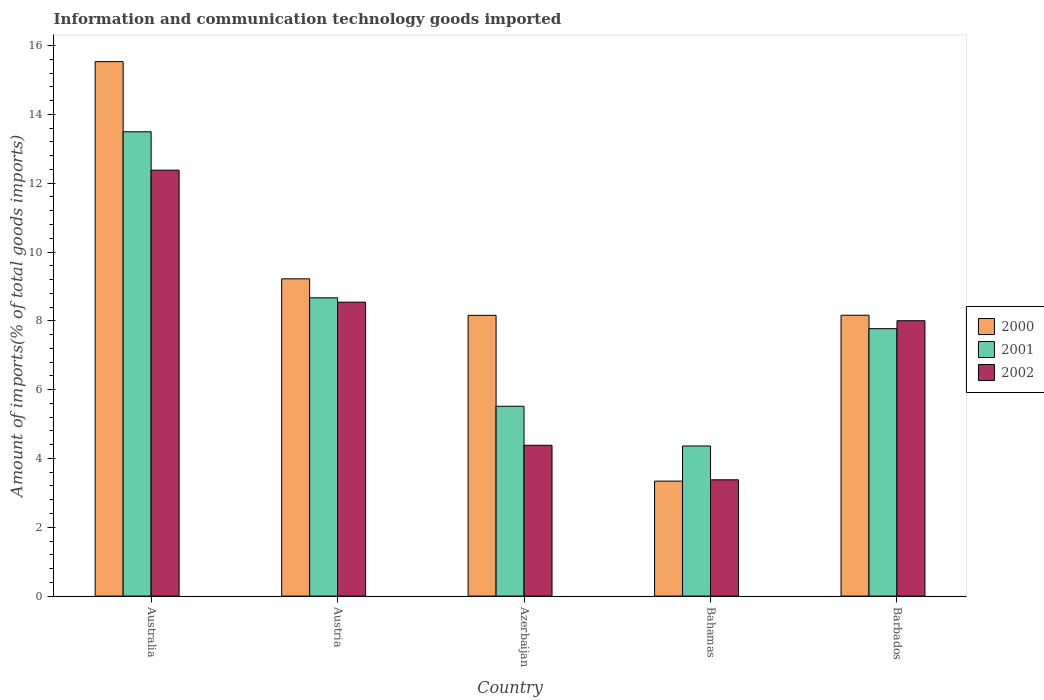How many different coloured bars are there?
Offer a very short reply. 3. How many groups of bars are there?
Your answer should be very brief. 5. Are the number of bars on each tick of the X-axis equal?
Your answer should be very brief. Yes. How many bars are there on the 5th tick from the left?
Keep it short and to the point. 3. What is the label of the 1st group of bars from the left?
Make the answer very short. Australia. In how many cases, is the number of bars for a given country not equal to the number of legend labels?
Your answer should be very brief. 0. What is the amount of goods imported in 2000 in Barbados?
Ensure brevity in your answer.  8.16. Across all countries, what is the maximum amount of goods imported in 2001?
Give a very brief answer. 13.49. Across all countries, what is the minimum amount of goods imported in 2001?
Offer a very short reply. 4.36. In which country was the amount of goods imported in 2000 minimum?
Make the answer very short. Bahamas. What is the total amount of goods imported in 2000 in the graph?
Your answer should be very brief. 44.42. What is the difference between the amount of goods imported in 2002 in Australia and that in Bahamas?
Your answer should be very brief. 9. What is the difference between the amount of goods imported in 2000 in Australia and the amount of goods imported in 2002 in Barbados?
Your answer should be very brief. 7.53. What is the average amount of goods imported in 2001 per country?
Your answer should be compact. 7.96. What is the difference between the amount of goods imported of/in 2001 and amount of goods imported of/in 2002 in Bahamas?
Offer a terse response. 0.98. In how many countries, is the amount of goods imported in 2001 greater than 11.6 %?
Provide a succinct answer. 1. What is the ratio of the amount of goods imported in 2001 in Australia to that in Azerbaijan?
Your answer should be compact. 2.45. Is the difference between the amount of goods imported in 2001 in Australia and Bahamas greater than the difference between the amount of goods imported in 2002 in Australia and Bahamas?
Make the answer very short. Yes. What is the difference between the highest and the second highest amount of goods imported in 2000?
Provide a short and direct response. -1.06. What is the difference between the highest and the lowest amount of goods imported in 2002?
Offer a very short reply. 9. What does the 2nd bar from the left in Austria represents?
Your answer should be very brief. 2001. Is it the case that in every country, the sum of the amount of goods imported in 2002 and amount of goods imported in 2001 is greater than the amount of goods imported in 2000?
Keep it short and to the point. Yes. How many bars are there?
Ensure brevity in your answer.  15. How many countries are there in the graph?
Your response must be concise. 5. What is the difference between two consecutive major ticks on the Y-axis?
Make the answer very short. 2. Are the values on the major ticks of Y-axis written in scientific E-notation?
Your answer should be very brief. No. Does the graph contain grids?
Offer a very short reply. No. Where does the legend appear in the graph?
Ensure brevity in your answer.  Center right. How are the legend labels stacked?
Make the answer very short. Vertical. What is the title of the graph?
Your response must be concise. Information and communication technology goods imported. What is the label or title of the Y-axis?
Offer a very short reply. Amount of imports(% of total goods imports). What is the Amount of imports(% of total goods imports) in 2000 in Australia?
Offer a terse response. 15.53. What is the Amount of imports(% of total goods imports) of 2001 in Australia?
Make the answer very short. 13.49. What is the Amount of imports(% of total goods imports) in 2002 in Australia?
Make the answer very short. 12.38. What is the Amount of imports(% of total goods imports) in 2000 in Austria?
Make the answer very short. 9.22. What is the Amount of imports(% of total goods imports) of 2001 in Austria?
Offer a very short reply. 8.67. What is the Amount of imports(% of total goods imports) in 2002 in Austria?
Offer a very short reply. 8.54. What is the Amount of imports(% of total goods imports) in 2000 in Azerbaijan?
Offer a very short reply. 8.16. What is the Amount of imports(% of total goods imports) of 2001 in Azerbaijan?
Provide a succinct answer. 5.52. What is the Amount of imports(% of total goods imports) in 2002 in Azerbaijan?
Your answer should be compact. 4.38. What is the Amount of imports(% of total goods imports) of 2000 in Bahamas?
Keep it short and to the point. 3.34. What is the Amount of imports(% of total goods imports) in 2001 in Bahamas?
Provide a short and direct response. 4.36. What is the Amount of imports(% of total goods imports) of 2002 in Bahamas?
Provide a short and direct response. 3.38. What is the Amount of imports(% of total goods imports) of 2000 in Barbados?
Keep it short and to the point. 8.16. What is the Amount of imports(% of total goods imports) in 2001 in Barbados?
Your response must be concise. 7.77. What is the Amount of imports(% of total goods imports) of 2002 in Barbados?
Ensure brevity in your answer.  8. Across all countries, what is the maximum Amount of imports(% of total goods imports) of 2000?
Your answer should be compact. 15.53. Across all countries, what is the maximum Amount of imports(% of total goods imports) in 2001?
Provide a short and direct response. 13.49. Across all countries, what is the maximum Amount of imports(% of total goods imports) of 2002?
Offer a terse response. 12.38. Across all countries, what is the minimum Amount of imports(% of total goods imports) of 2000?
Provide a succinct answer. 3.34. Across all countries, what is the minimum Amount of imports(% of total goods imports) of 2001?
Make the answer very short. 4.36. Across all countries, what is the minimum Amount of imports(% of total goods imports) of 2002?
Provide a succinct answer. 3.38. What is the total Amount of imports(% of total goods imports) in 2000 in the graph?
Give a very brief answer. 44.42. What is the total Amount of imports(% of total goods imports) in 2001 in the graph?
Make the answer very short. 39.82. What is the total Amount of imports(% of total goods imports) in 2002 in the graph?
Provide a succinct answer. 36.69. What is the difference between the Amount of imports(% of total goods imports) of 2000 in Australia and that in Austria?
Make the answer very short. 6.31. What is the difference between the Amount of imports(% of total goods imports) of 2001 in Australia and that in Austria?
Offer a terse response. 4.83. What is the difference between the Amount of imports(% of total goods imports) in 2002 in Australia and that in Austria?
Provide a succinct answer. 3.84. What is the difference between the Amount of imports(% of total goods imports) of 2000 in Australia and that in Azerbaijan?
Ensure brevity in your answer.  7.37. What is the difference between the Amount of imports(% of total goods imports) of 2001 in Australia and that in Azerbaijan?
Keep it short and to the point. 7.98. What is the difference between the Amount of imports(% of total goods imports) in 2002 in Australia and that in Azerbaijan?
Your answer should be very brief. 8. What is the difference between the Amount of imports(% of total goods imports) in 2000 in Australia and that in Bahamas?
Ensure brevity in your answer.  12.19. What is the difference between the Amount of imports(% of total goods imports) of 2001 in Australia and that in Bahamas?
Your response must be concise. 9.13. What is the difference between the Amount of imports(% of total goods imports) of 2002 in Australia and that in Bahamas?
Offer a very short reply. 9. What is the difference between the Amount of imports(% of total goods imports) in 2000 in Australia and that in Barbados?
Give a very brief answer. 7.37. What is the difference between the Amount of imports(% of total goods imports) in 2001 in Australia and that in Barbados?
Ensure brevity in your answer.  5.72. What is the difference between the Amount of imports(% of total goods imports) of 2002 in Australia and that in Barbados?
Offer a very short reply. 4.38. What is the difference between the Amount of imports(% of total goods imports) of 2000 in Austria and that in Azerbaijan?
Provide a succinct answer. 1.06. What is the difference between the Amount of imports(% of total goods imports) in 2001 in Austria and that in Azerbaijan?
Make the answer very short. 3.15. What is the difference between the Amount of imports(% of total goods imports) of 2002 in Austria and that in Azerbaijan?
Your answer should be very brief. 4.16. What is the difference between the Amount of imports(% of total goods imports) in 2000 in Austria and that in Bahamas?
Provide a short and direct response. 5.88. What is the difference between the Amount of imports(% of total goods imports) of 2001 in Austria and that in Bahamas?
Offer a very short reply. 4.31. What is the difference between the Amount of imports(% of total goods imports) in 2002 in Austria and that in Bahamas?
Your response must be concise. 5.16. What is the difference between the Amount of imports(% of total goods imports) of 2000 in Austria and that in Barbados?
Ensure brevity in your answer.  1.06. What is the difference between the Amount of imports(% of total goods imports) in 2001 in Austria and that in Barbados?
Your response must be concise. 0.9. What is the difference between the Amount of imports(% of total goods imports) of 2002 in Austria and that in Barbados?
Your answer should be very brief. 0.54. What is the difference between the Amount of imports(% of total goods imports) in 2000 in Azerbaijan and that in Bahamas?
Your response must be concise. 4.82. What is the difference between the Amount of imports(% of total goods imports) of 2001 in Azerbaijan and that in Bahamas?
Your answer should be compact. 1.15. What is the difference between the Amount of imports(% of total goods imports) in 2002 in Azerbaijan and that in Bahamas?
Make the answer very short. 1. What is the difference between the Amount of imports(% of total goods imports) of 2000 in Azerbaijan and that in Barbados?
Offer a very short reply. -0. What is the difference between the Amount of imports(% of total goods imports) in 2001 in Azerbaijan and that in Barbados?
Ensure brevity in your answer.  -2.26. What is the difference between the Amount of imports(% of total goods imports) of 2002 in Azerbaijan and that in Barbados?
Offer a very short reply. -3.62. What is the difference between the Amount of imports(% of total goods imports) of 2000 in Bahamas and that in Barbados?
Ensure brevity in your answer.  -4.82. What is the difference between the Amount of imports(% of total goods imports) in 2001 in Bahamas and that in Barbados?
Your answer should be compact. -3.41. What is the difference between the Amount of imports(% of total goods imports) in 2002 in Bahamas and that in Barbados?
Give a very brief answer. -4.62. What is the difference between the Amount of imports(% of total goods imports) in 2000 in Australia and the Amount of imports(% of total goods imports) in 2001 in Austria?
Provide a succinct answer. 6.87. What is the difference between the Amount of imports(% of total goods imports) of 2000 in Australia and the Amount of imports(% of total goods imports) of 2002 in Austria?
Keep it short and to the point. 6.99. What is the difference between the Amount of imports(% of total goods imports) in 2001 in Australia and the Amount of imports(% of total goods imports) in 2002 in Austria?
Offer a very short reply. 4.95. What is the difference between the Amount of imports(% of total goods imports) of 2000 in Australia and the Amount of imports(% of total goods imports) of 2001 in Azerbaijan?
Offer a very short reply. 10.02. What is the difference between the Amount of imports(% of total goods imports) in 2000 in Australia and the Amount of imports(% of total goods imports) in 2002 in Azerbaijan?
Make the answer very short. 11.15. What is the difference between the Amount of imports(% of total goods imports) in 2001 in Australia and the Amount of imports(% of total goods imports) in 2002 in Azerbaijan?
Offer a terse response. 9.11. What is the difference between the Amount of imports(% of total goods imports) in 2000 in Australia and the Amount of imports(% of total goods imports) in 2001 in Bahamas?
Keep it short and to the point. 11.17. What is the difference between the Amount of imports(% of total goods imports) of 2000 in Australia and the Amount of imports(% of total goods imports) of 2002 in Bahamas?
Make the answer very short. 12.15. What is the difference between the Amount of imports(% of total goods imports) in 2001 in Australia and the Amount of imports(% of total goods imports) in 2002 in Bahamas?
Your response must be concise. 10.11. What is the difference between the Amount of imports(% of total goods imports) in 2000 in Australia and the Amount of imports(% of total goods imports) in 2001 in Barbados?
Your answer should be very brief. 7.76. What is the difference between the Amount of imports(% of total goods imports) in 2000 in Australia and the Amount of imports(% of total goods imports) in 2002 in Barbados?
Your response must be concise. 7.53. What is the difference between the Amount of imports(% of total goods imports) of 2001 in Australia and the Amount of imports(% of total goods imports) of 2002 in Barbados?
Offer a very short reply. 5.49. What is the difference between the Amount of imports(% of total goods imports) of 2000 in Austria and the Amount of imports(% of total goods imports) of 2001 in Azerbaijan?
Give a very brief answer. 3.7. What is the difference between the Amount of imports(% of total goods imports) in 2000 in Austria and the Amount of imports(% of total goods imports) in 2002 in Azerbaijan?
Provide a succinct answer. 4.84. What is the difference between the Amount of imports(% of total goods imports) in 2001 in Austria and the Amount of imports(% of total goods imports) in 2002 in Azerbaijan?
Provide a short and direct response. 4.29. What is the difference between the Amount of imports(% of total goods imports) in 2000 in Austria and the Amount of imports(% of total goods imports) in 2001 in Bahamas?
Offer a very short reply. 4.86. What is the difference between the Amount of imports(% of total goods imports) in 2000 in Austria and the Amount of imports(% of total goods imports) in 2002 in Bahamas?
Provide a short and direct response. 5.84. What is the difference between the Amount of imports(% of total goods imports) of 2001 in Austria and the Amount of imports(% of total goods imports) of 2002 in Bahamas?
Your answer should be very brief. 5.29. What is the difference between the Amount of imports(% of total goods imports) of 2000 in Austria and the Amount of imports(% of total goods imports) of 2001 in Barbados?
Offer a very short reply. 1.45. What is the difference between the Amount of imports(% of total goods imports) of 2000 in Austria and the Amount of imports(% of total goods imports) of 2002 in Barbados?
Your answer should be compact. 1.22. What is the difference between the Amount of imports(% of total goods imports) of 2001 in Austria and the Amount of imports(% of total goods imports) of 2002 in Barbados?
Keep it short and to the point. 0.66. What is the difference between the Amount of imports(% of total goods imports) of 2000 in Azerbaijan and the Amount of imports(% of total goods imports) of 2001 in Bahamas?
Provide a short and direct response. 3.8. What is the difference between the Amount of imports(% of total goods imports) in 2000 in Azerbaijan and the Amount of imports(% of total goods imports) in 2002 in Bahamas?
Give a very brief answer. 4.78. What is the difference between the Amount of imports(% of total goods imports) of 2001 in Azerbaijan and the Amount of imports(% of total goods imports) of 2002 in Bahamas?
Offer a very short reply. 2.14. What is the difference between the Amount of imports(% of total goods imports) of 2000 in Azerbaijan and the Amount of imports(% of total goods imports) of 2001 in Barbados?
Keep it short and to the point. 0.39. What is the difference between the Amount of imports(% of total goods imports) of 2000 in Azerbaijan and the Amount of imports(% of total goods imports) of 2002 in Barbados?
Give a very brief answer. 0.16. What is the difference between the Amount of imports(% of total goods imports) in 2001 in Azerbaijan and the Amount of imports(% of total goods imports) in 2002 in Barbados?
Make the answer very short. -2.49. What is the difference between the Amount of imports(% of total goods imports) in 2000 in Bahamas and the Amount of imports(% of total goods imports) in 2001 in Barbados?
Your answer should be very brief. -4.43. What is the difference between the Amount of imports(% of total goods imports) in 2000 in Bahamas and the Amount of imports(% of total goods imports) in 2002 in Barbados?
Offer a very short reply. -4.66. What is the difference between the Amount of imports(% of total goods imports) in 2001 in Bahamas and the Amount of imports(% of total goods imports) in 2002 in Barbados?
Your answer should be compact. -3.64. What is the average Amount of imports(% of total goods imports) in 2000 per country?
Offer a very short reply. 8.88. What is the average Amount of imports(% of total goods imports) in 2001 per country?
Offer a terse response. 7.96. What is the average Amount of imports(% of total goods imports) of 2002 per country?
Your answer should be compact. 7.34. What is the difference between the Amount of imports(% of total goods imports) of 2000 and Amount of imports(% of total goods imports) of 2001 in Australia?
Keep it short and to the point. 2.04. What is the difference between the Amount of imports(% of total goods imports) in 2000 and Amount of imports(% of total goods imports) in 2002 in Australia?
Provide a succinct answer. 3.16. What is the difference between the Amount of imports(% of total goods imports) of 2001 and Amount of imports(% of total goods imports) of 2002 in Australia?
Offer a very short reply. 1.12. What is the difference between the Amount of imports(% of total goods imports) of 2000 and Amount of imports(% of total goods imports) of 2001 in Austria?
Make the answer very short. 0.55. What is the difference between the Amount of imports(% of total goods imports) in 2000 and Amount of imports(% of total goods imports) in 2002 in Austria?
Your answer should be very brief. 0.68. What is the difference between the Amount of imports(% of total goods imports) in 2001 and Amount of imports(% of total goods imports) in 2002 in Austria?
Your answer should be very brief. 0.13. What is the difference between the Amount of imports(% of total goods imports) in 2000 and Amount of imports(% of total goods imports) in 2001 in Azerbaijan?
Ensure brevity in your answer.  2.64. What is the difference between the Amount of imports(% of total goods imports) of 2000 and Amount of imports(% of total goods imports) of 2002 in Azerbaijan?
Offer a terse response. 3.78. What is the difference between the Amount of imports(% of total goods imports) of 2001 and Amount of imports(% of total goods imports) of 2002 in Azerbaijan?
Offer a terse response. 1.13. What is the difference between the Amount of imports(% of total goods imports) in 2000 and Amount of imports(% of total goods imports) in 2001 in Bahamas?
Your response must be concise. -1.02. What is the difference between the Amount of imports(% of total goods imports) in 2000 and Amount of imports(% of total goods imports) in 2002 in Bahamas?
Provide a short and direct response. -0.04. What is the difference between the Amount of imports(% of total goods imports) of 2001 and Amount of imports(% of total goods imports) of 2002 in Bahamas?
Your answer should be very brief. 0.98. What is the difference between the Amount of imports(% of total goods imports) of 2000 and Amount of imports(% of total goods imports) of 2001 in Barbados?
Ensure brevity in your answer.  0.39. What is the difference between the Amount of imports(% of total goods imports) in 2000 and Amount of imports(% of total goods imports) in 2002 in Barbados?
Your answer should be compact. 0.16. What is the difference between the Amount of imports(% of total goods imports) in 2001 and Amount of imports(% of total goods imports) in 2002 in Barbados?
Offer a terse response. -0.23. What is the ratio of the Amount of imports(% of total goods imports) of 2000 in Australia to that in Austria?
Your answer should be very brief. 1.68. What is the ratio of the Amount of imports(% of total goods imports) of 2001 in Australia to that in Austria?
Provide a short and direct response. 1.56. What is the ratio of the Amount of imports(% of total goods imports) in 2002 in Australia to that in Austria?
Ensure brevity in your answer.  1.45. What is the ratio of the Amount of imports(% of total goods imports) of 2000 in Australia to that in Azerbaijan?
Your response must be concise. 1.9. What is the ratio of the Amount of imports(% of total goods imports) of 2001 in Australia to that in Azerbaijan?
Offer a very short reply. 2.45. What is the ratio of the Amount of imports(% of total goods imports) in 2002 in Australia to that in Azerbaijan?
Give a very brief answer. 2.82. What is the ratio of the Amount of imports(% of total goods imports) in 2000 in Australia to that in Bahamas?
Your response must be concise. 4.65. What is the ratio of the Amount of imports(% of total goods imports) in 2001 in Australia to that in Bahamas?
Your answer should be compact. 3.09. What is the ratio of the Amount of imports(% of total goods imports) in 2002 in Australia to that in Bahamas?
Offer a very short reply. 3.66. What is the ratio of the Amount of imports(% of total goods imports) in 2000 in Australia to that in Barbados?
Ensure brevity in your answer.  1.9. What is the ratio of the Amount of imports(% of total goods imports) of 2001 in Australia to that in Barbados?
Provide a succinct answer. 1.74. What is the ratio of the Amount of imports(% of total goods imports) of 2002 in Australia to that in Barbados?
Keep it short and to the point. 1.55. What is the ratio of the Amount of imports(% of total goods imports) of 2000 in Austria to that in Azerbaijan?
Provide a succinct answer. 1.13. What is the ratio of the Amount of imports(% of total goods imports) of 2001 in Austria to that in Azerbaijan?
Your response must be concise. 1.57. What is the ratio of the Amount of imports(% of total goods imports) of 2002 in Austria to that in Azerbaijan?
Keep it short and to the point. 1.95. What is the ratio of the Amount of imports(% of total goods imports) in 2000 in Austria to that in Bahamas?
Make the answer very short. 2.76. What is the ratio of the Amount of imports(% of total goods imports) of 2001 in Austria to that in Bahamas?
Offer a terse response. 1.99. What is the ratio of the Amount of imports(% of total goods imports) in 2002 in Austria to that in Bahamas?
Your response must be concise. 2.53. What is the ratio of the Amount of imports(% of total goods imports) of 2000 in Austria to that in Barbados?
Your response must be concise. 1.13. What is the ratio of the Amount of imports(% of total goods imports) of 2001 in Austria to that in Barbados?
Ensure brevity in your answer.  1.12. What is the ratio of the Amount of imports(% of total goods imports) in 2002 in Austria to that in Barbados?
Provide a succinct answer. 1.07. What is the ratio of the Amount of imports(% of total goods imports) of 2000 in Azerbaijan to that in Bahamas?
Give a very brief answer. 2.44. What is the ratio of the Amount of imports(% of total goods imports) of 2001 in Azerbaijan to that in Bahamas?
Your response must be concise. 1.26. What is the ratio of the Amount of imports(% of total goods imports) in 2002 in Azerbaijan to that in Bahamas?
Offer a very short reply. 1.3. What is the ratio of the Amount of imports(% of total goods imports) of 2001 in Azerbaijan to that in Barbados?
Ensure brevity in your answer.  0.71. What is the ratio of the Amount of imports(% of total goods imports) in 2002 in Azerbaijan to that in Barbados?
Keep it short and to the point. 0.55. What is the ratio of the Amount of imports(% of total goods imports) of 2000 in Bahamas to that in Barbados?
Keep it short and to the point. 0.41. What is the ratio of the Amount of imports(% of total goods imports) in 2001 in Bahamas to that in Barbados?
Your response must be concise. 0.56. What is the ratio of the Amount of imports(% of total goods imports) of 2002 in Bahamas to that in Barbados?
Provide a succinct answer. 0.42. What is the difference between the highest and the second highest Amount of imports(% of total goods imports) in 2000?
Your response must be concise. 6.31. What is the difference between the highest and the second highest Amount of imports(% of total goods imports) of 2001?
Make the answer very short. 4.83. What is the difference between the highest and the second highest Amount of imports(% of total goods imports) in 2002?
Offer a terse response. 3.84. What is the difference between the highest and the lowest Amount of imports(% of total goods imports) in 2000?
Offer a very short reply. 12.19. What is the difference between the highest and the lowest Amount of imports(% of total goods imports) of 2001?
Give a very brief answer. 9.13. What is the difference between the highest and the lowest Amount of imports(% of total goods imports) of 2002?
Give a very brief answer. 9. 